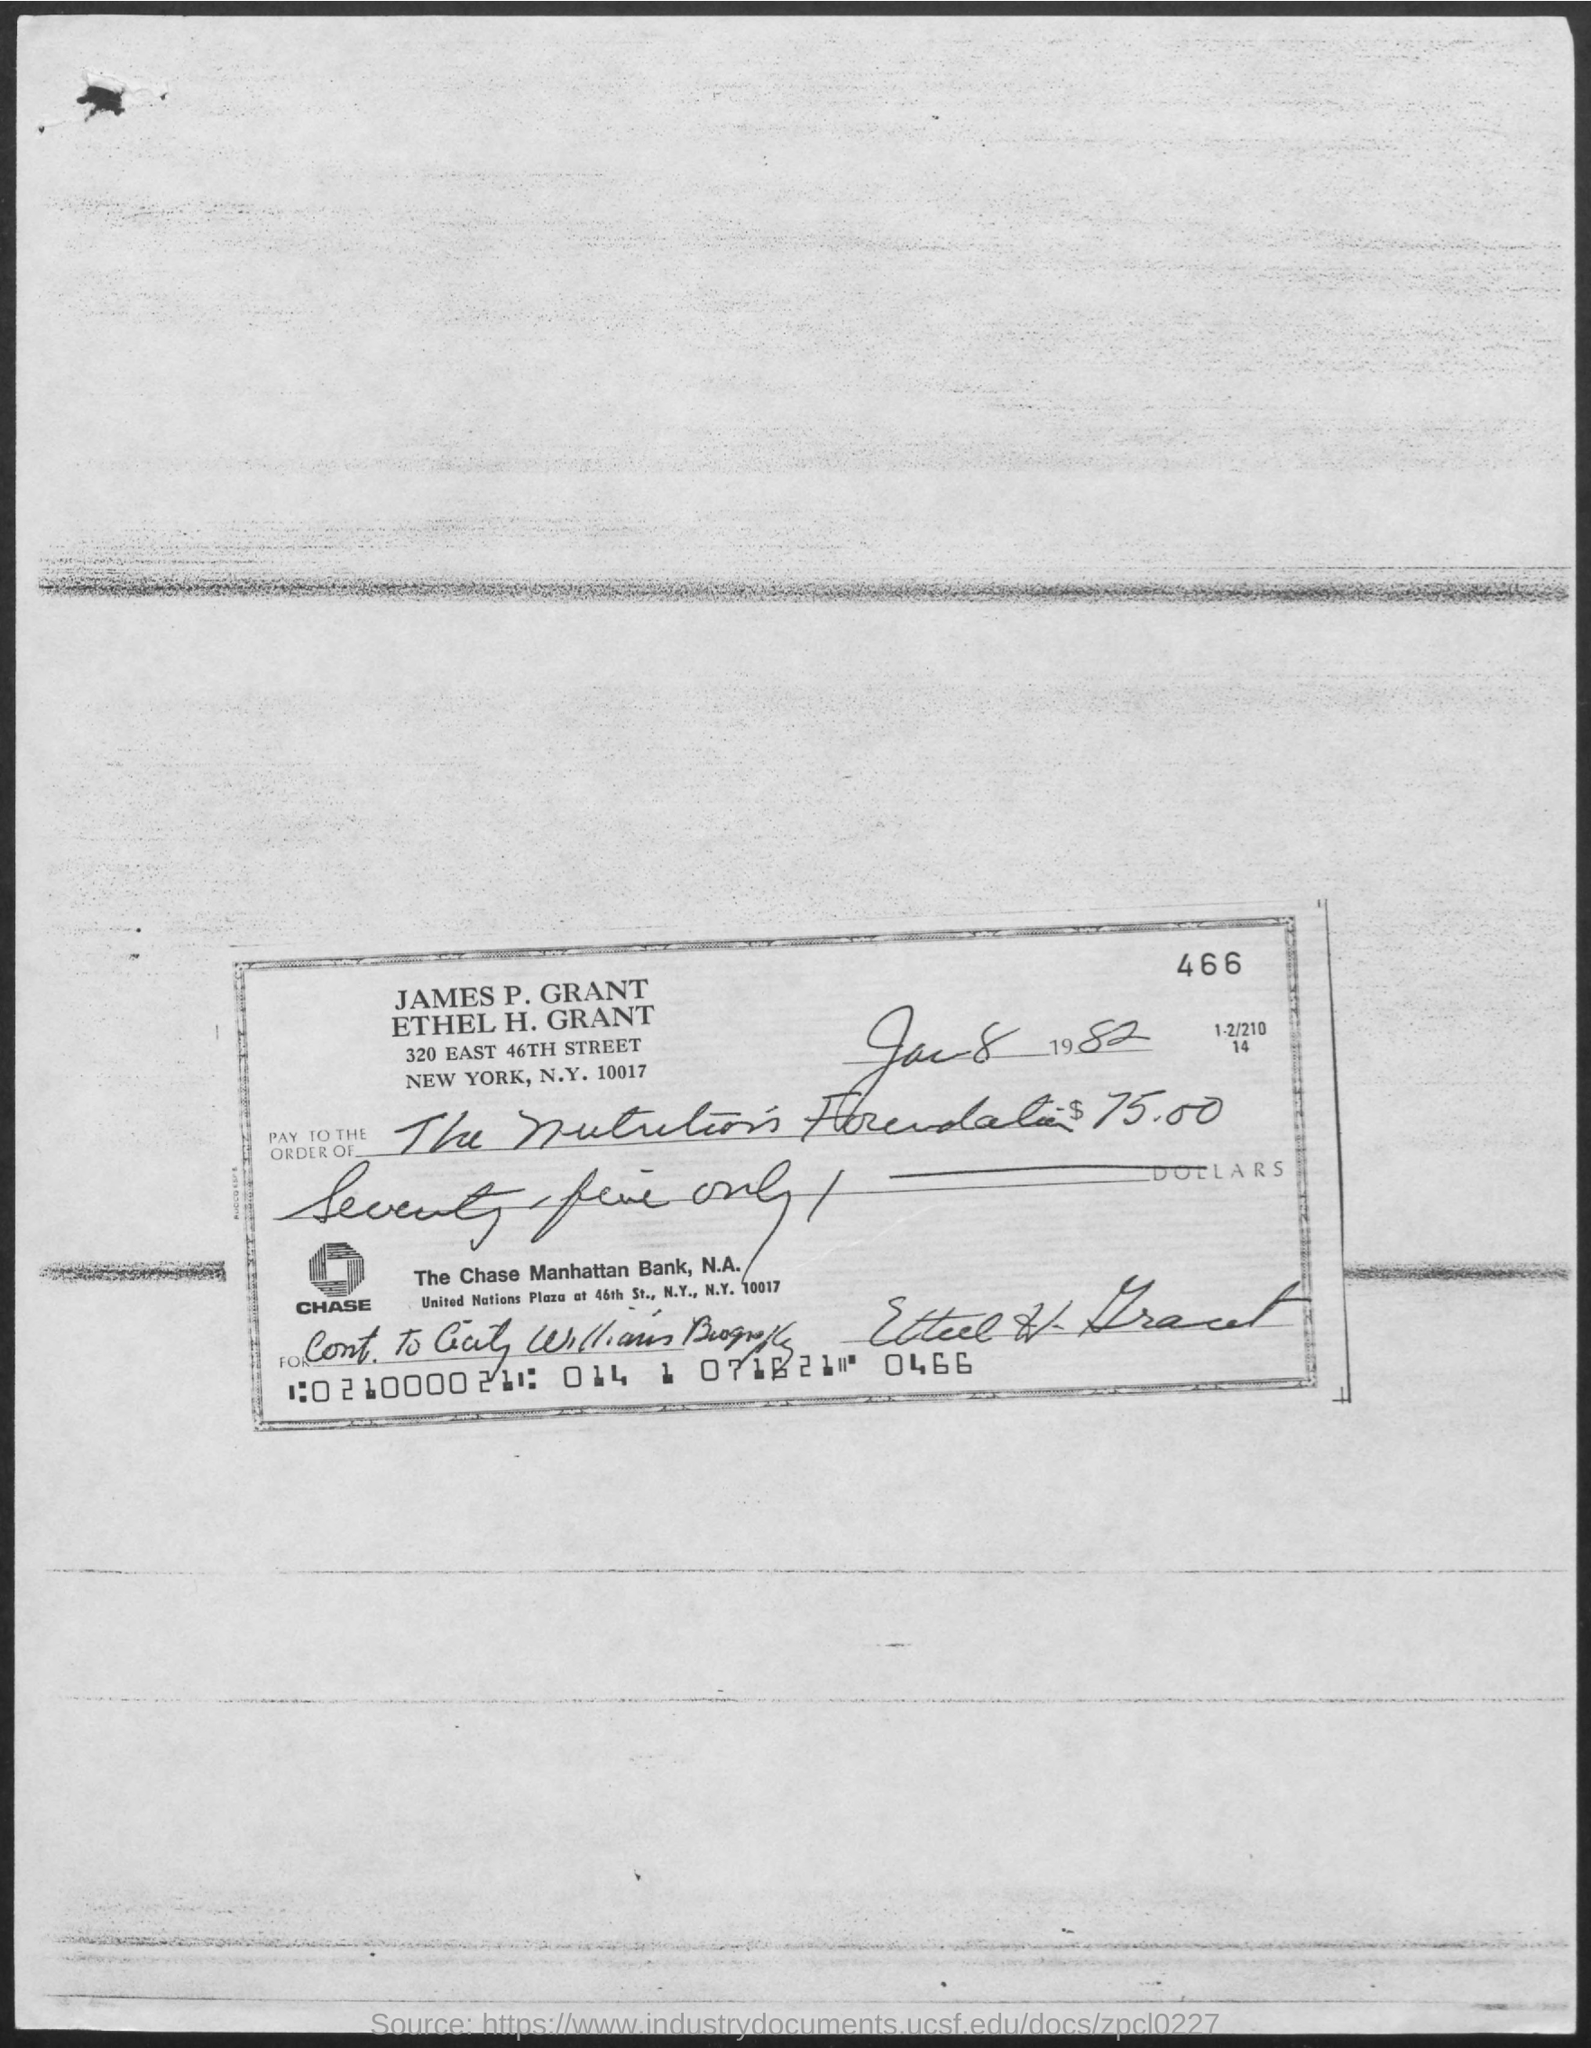What date is written in the cheque?
Your answer should be compact. Jan 8, 1982. 